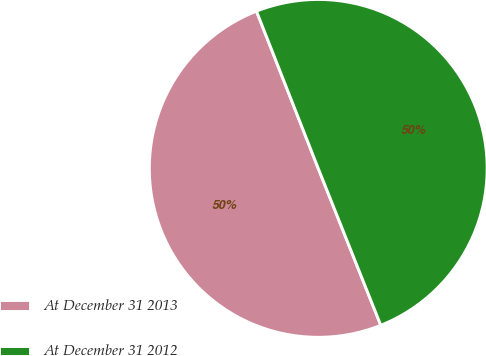Convert chart. <chart><loc_0><loc_0><loc_500><loc_500><pie_chart><fcel>At December 31 2013<fcel>At December 31 2012<nl><fcel>50.08%<fcel>49.92%<nl></chart> 